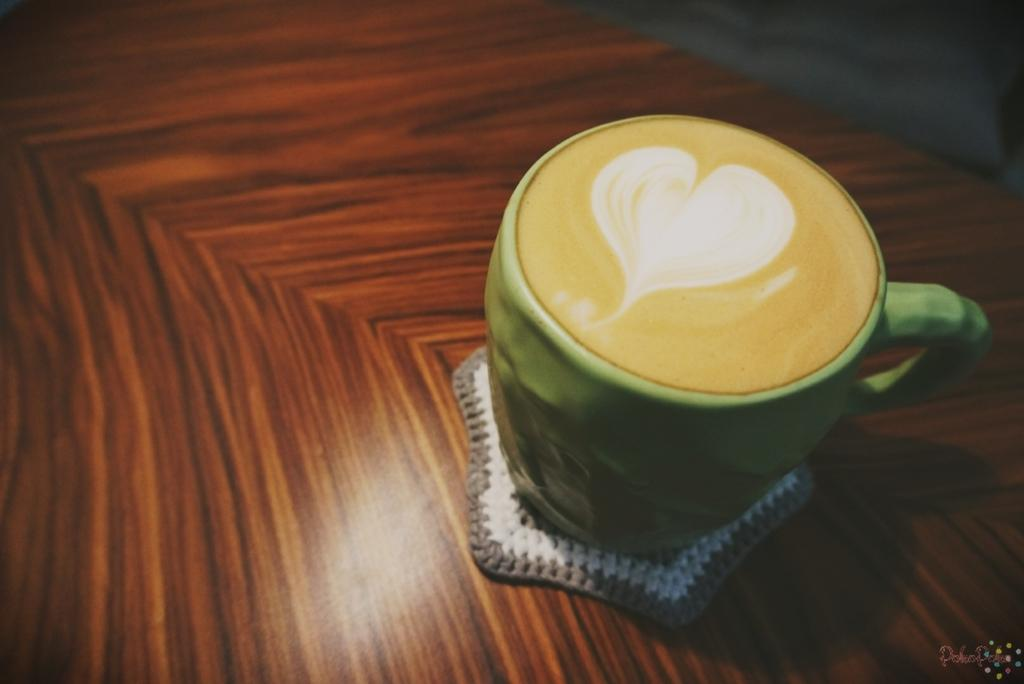What is in the cup that is visible in the image? There is a cup of coffee in the image. Where is the cup placed in the image? The cup is placed on a wooden table. What can be seen on the right side of the image? There is some text on the right side of the image. Can you see a van parked next to the table in the image? No, there is no van present in the image. Is there a duck sitting on the table next to the cup of coffee? No, there is no duck present in the image. 